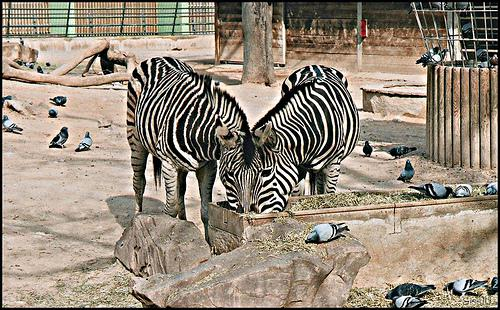Question: where was the photo taken?
Choices:
A. Park.
B. City.
C. Farm.
D. Zoo.
Answer with the letter. Answer: D Question: what are the zebras doing?
Choices:
A. Eating.
B. Walking.
C. Running.
D. Jumping.
Answer with the letter. Answer: A Question: what are the zebras' surroundings like?
Choices:
A. Scrubby and dirty.
B. Green and lush.
C. In a forest.
D. Rocky and barren.
Answer with the letter. Answer: D Question: what animals are at the center of the photo?
Choices:
A. Zebras.
B. Lions.
C. Tigers.
D. Giraffes.
Answer with the letter. Answer: A Question: how many zebras are there?
Choices:
A. 5.
B. 1.
C. 2.
D. 3.
Answer with the letter. Answer: C Question: what animals besides zebras are in the photo?
Choices:
A. Parrots.
B. Crows.
C. Finches.
D. Pigeons.
Answer with the letter. Answer: D Question: what corner of the photo has the most empty space?
Choices:
A. Lower left.
B. Lower right.
C. Upper right.
D. Upper left.
Answer with the letter. Answer: A 